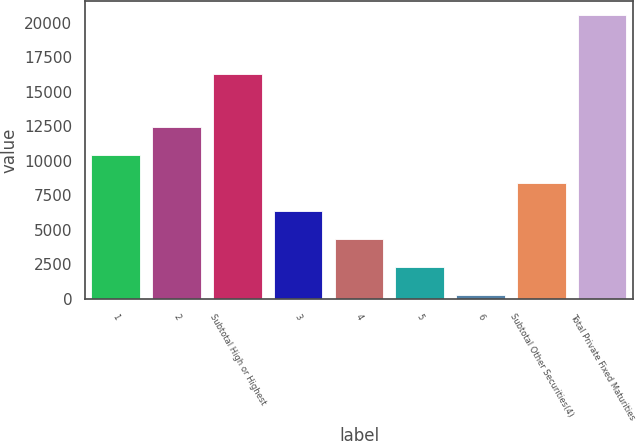Convert chart to OTSL. <chart><loc_0><loc_0><loc_500><loc_500><bar_chart><fcel>1<fcel>2<fcel>Subtotal High or Highest<fcel>3<fcel>4<fcel>5<fcel>6<fcel>Subtotal Other Securities(4)<fcel>Total Private Fixed Maturities<nl><fcel>10436.5<fcel>12461.2<fcel>16305<fcel>6387.1<fcel>4362.4<fcel>2337.7<fcel>313<fcel>8411.8<fcel>20560<nl></chart> 